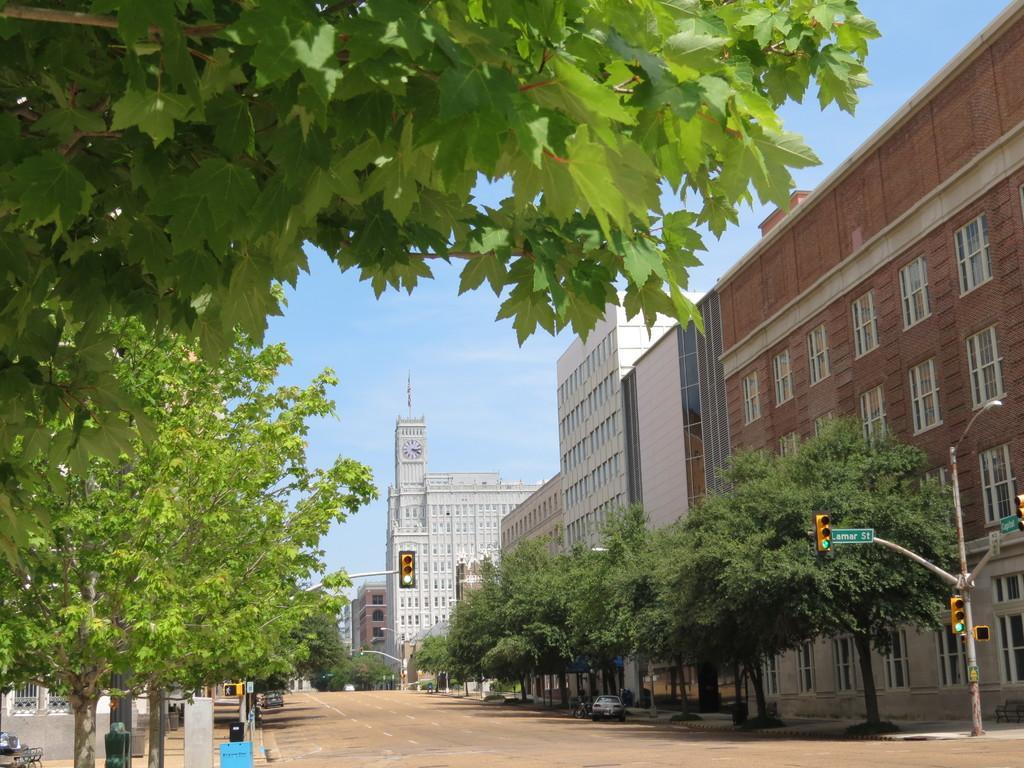How would you summarize this image in a sentence or two? In this image, we can see so many buildings, walls, glass windows, traffic signals, trees, sign boards, poles and clock. Here we can see few vehicles on the road. Background there is a sky. 